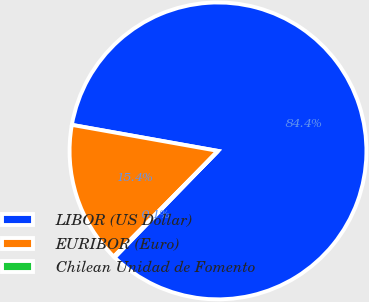<chart> <loc_0><loc_0><loc_500><loc_500><pie_chart><fcel>LIBOR (US Dollar)<fcel>EURIBOR (Euro)<fcel>Chilean Unidad de Fomento<nl><fcel>84.45%<fcel>15.42%<fcel>0.13%<nl></chart> 